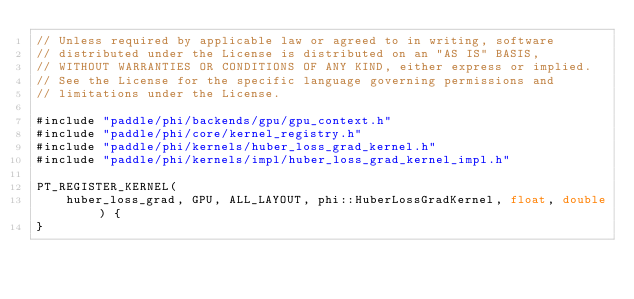<code> <loc_0><loc_0><loc_500><loc_500><_Cuda_>// Unless required by applicable law or agreed to in writing, software
// distributed under the License is distributed on an "AS IS" BASIS,
// WITHOUT WARRANTIES OR CONDITIONS OF ANY KIND, either express or implied.
// See the License for the specific language governing permissions and
// limitations under the License.

#include "paddle/phi/backends/gpu/gpu_context.h"
#include "paddle/phi/core/kernel_registry.h"
#include "paddle/phi/kernels/huber_loss_grad_kernel.h"
#include "paddle/phi/kernels/impl/huber_loss_grad_kernel_impl.h"

PT_REGISTER_KERNEL(
    huber_loss_grad, GPU, ALL_LAYOUT, phi::HuberLossGradKernel, float, double) {
}
</code> 